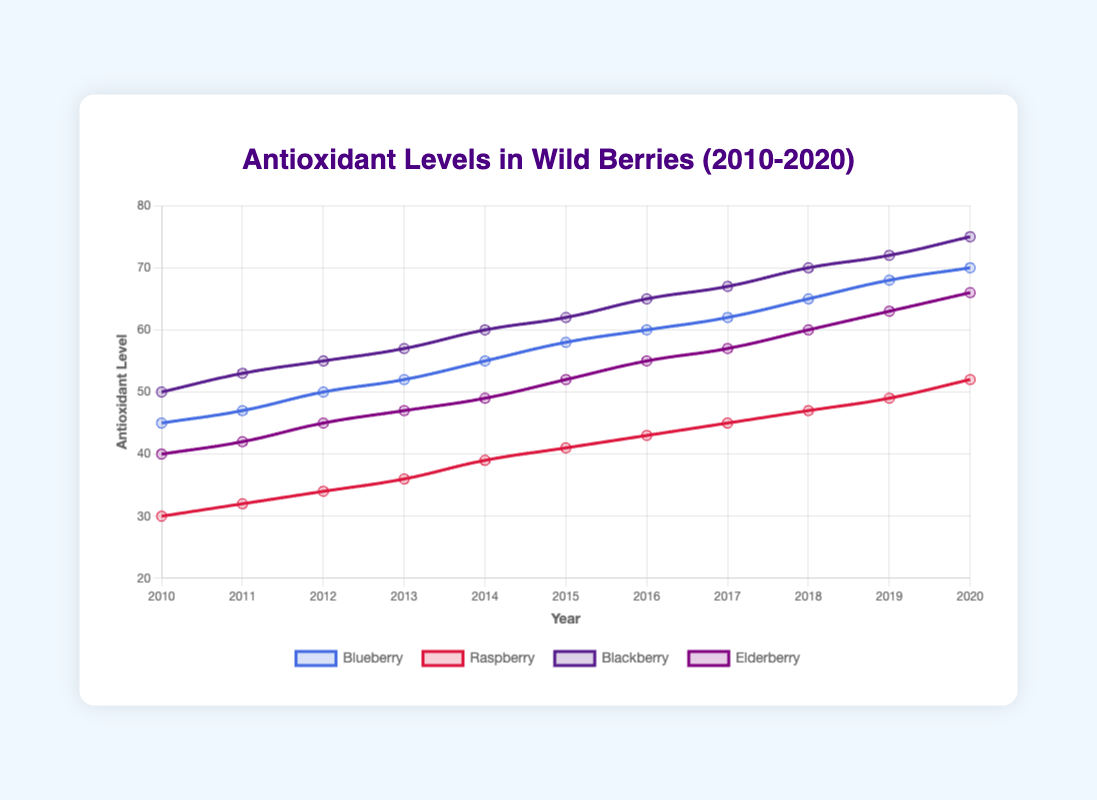What year did Blackberries reach their peak antioxidant level? Blackberries reached their peak antioxidant level in 2020, as indicated by the highest point on the line for Blackberries at that year.
Answer: 2020 Which berry had the lowest antioxidant level in 2010? In 2010, the berry with the lowest antioxidant level was Raspberry, as indicated by the lowest point on the graph for that year.
Answer: Raspberry How does the antioxidant level of Blueberries in 2015 compare to that of Raspberries in 2015? In 2015, Blueberries had an antioxidant level of 58, whereas Raspberries had an antioxidant level of 41. Therefore, Blueberries had higher antioxidant levels in 2015.
Answer: Blueberries are higher What was the overall trend in antioxidant levels for Elderberries from 2010 to 2020? For Elderberries, the antioxidant levels showed a consistent upward trend from 2010 to 2020, as evidenced by the steadily increasing line on the graph.
Answer: Increasing trend What is the average antioxidant level for Blueberries over the entire period? To find the average antioxidant level for Blueberries, sum the yearly levels from 2010 to 2020 and divide by the number of years: (45 + 47 + 50 + 52 + 55 + 58 + 60 + 62 + 65 + 68 + 70) / 11 = 57.
Answer: 57 Between which two consecutive years did Elderberries show the largest increase in antioxidant levels? The largest increase for Elderberries, visible in the steepest upward segment of the line, appears between 2018 (60) and 2019 (63), marking an increase of 3 units.
Answer: 2018 to 2019 By how much did Blackberries' antioxidant levels increase from 2010 to 2020? The increase is calculated by subtracting the level in 2010 (50) from the level in 2020 (75), giving us an increase of 75 - 50 = 25 units.
Answer: 25 units Compare the antioxidant levels of all berries in 2020. Which one had the highest level and which one had the lowest? In 2020, Blackberries had the highest antioxidant level (75), while Raspberries had the lowest (52), as indicated by the endpoint of each line.
Answer: Highest: Blackberries, Lowest: Raspberries 